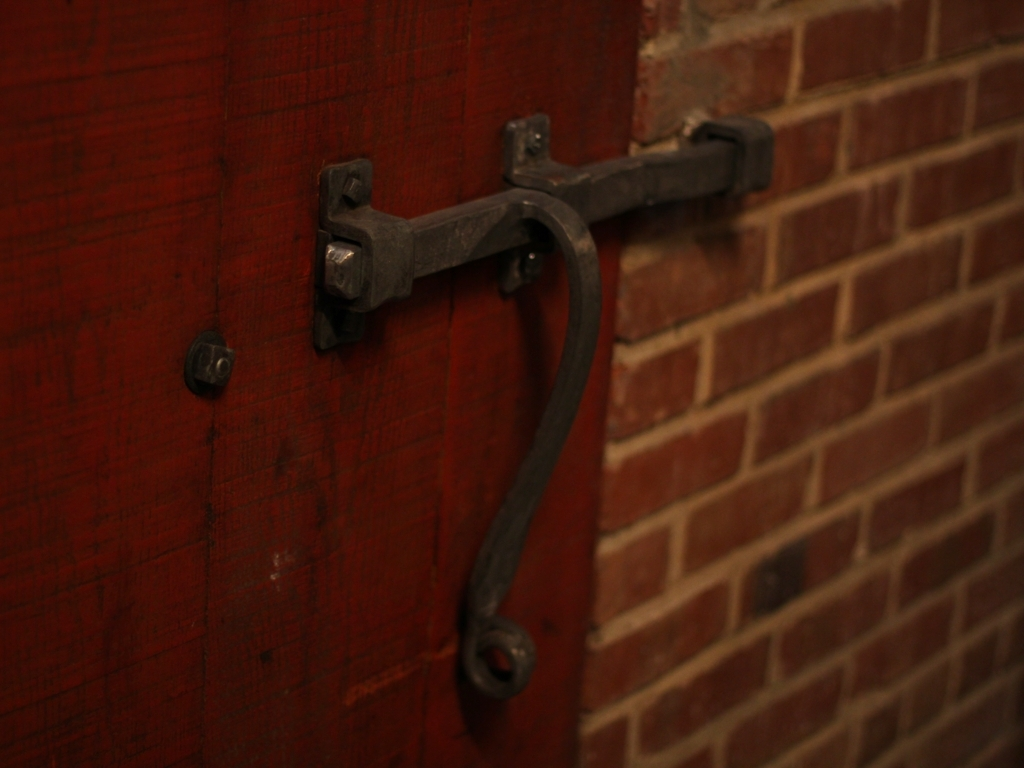How does the image composition contribute to the focus or mood of the picture? The composition, with its soft focus and shallow depth of field, directs attention to the metal latch's texture against the contrasting red door, enhancing its vintage look. The dim lighting and warm tones evoke a sense of nostalgia and mystery, underscoring the mood of the image. 